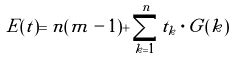Convert formula to latex. <formula><loc_0><loc_0><loc_500><loc_500>E ( t ) = n ( m - 1 ) + \sum _ { k = 1 } ^ { n } t _ { k } \cdot G ( k )</formula> 